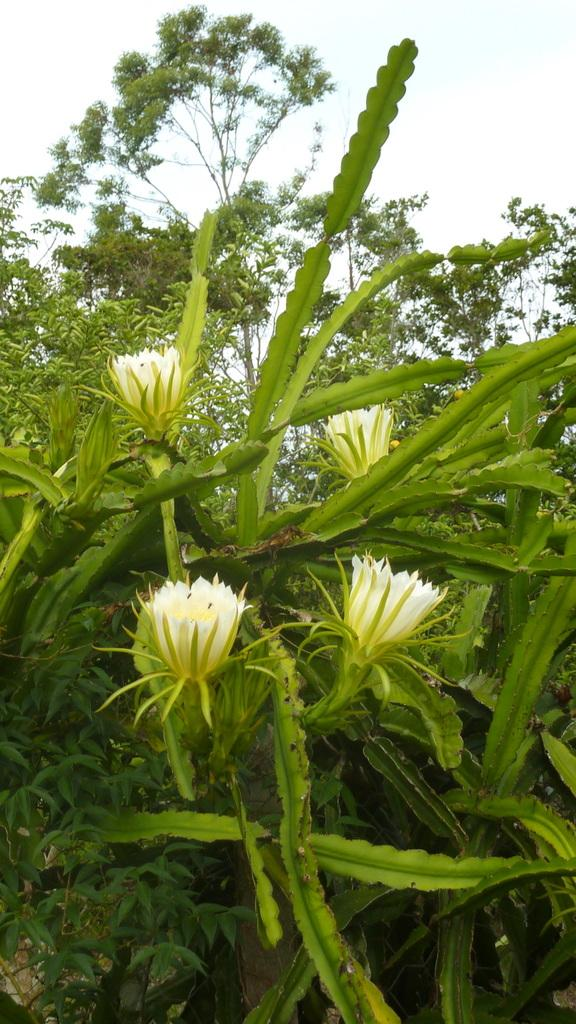What type of plants can be seen in the image? There are flowers and trees in the image. What part of the natural environment is visible in the image? The sky is visible in the image. What type of horn can be seen in the image? There is no horn present in the image. What part of the throat can be seen in the image? There is no throat present in the image. 